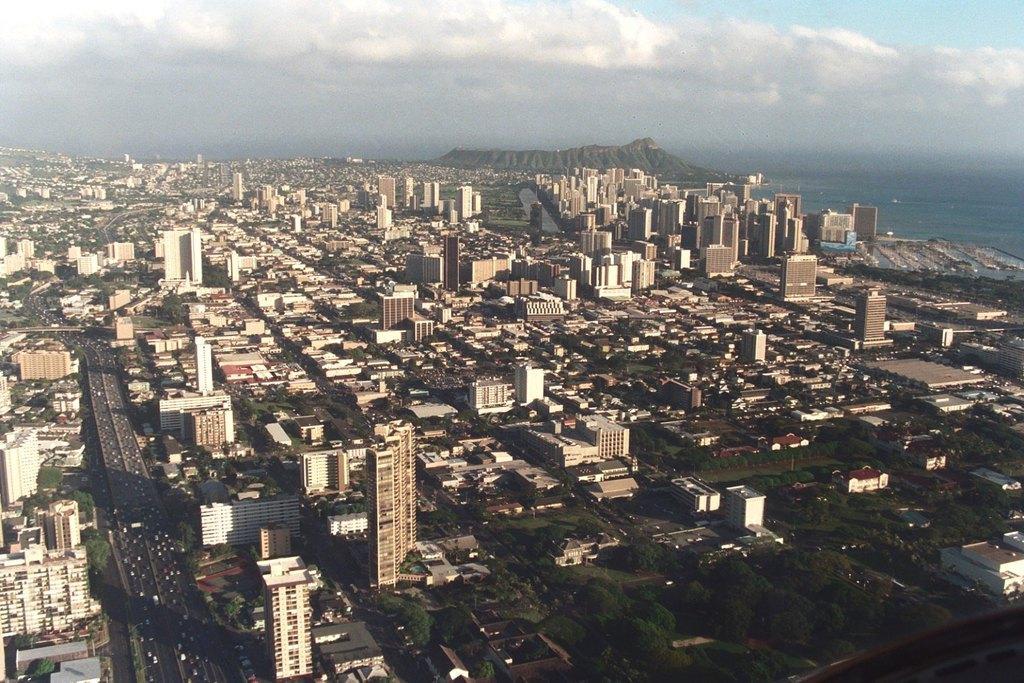Can you describe this image briefly? This image is an aerial view and we can see many buildings, trees, roads, hill and at the top there is sky. 